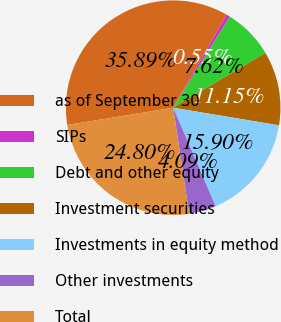Convert chart. <chart><loc_0><loc_0><loc_500><loc_500><pie_chart><fcel>as of September 30<fcel>SIPs<fcel>Debt and other equity<fcel>Investment securities<fcel>Investments in equity method<fcel>Other investments<fcel>Total<nl><fcel>35.89%<fcel>0.55%<fcel>7.62%<fcel>11.15%<fcel>15.9%<fcel>4.09%<fcel>24.8%<nl></chart> 